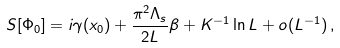Convert formula to latex. <formula><loc_0><loc_0><loc_500><loc_500>S [ \Phi _ { 0 } ] = i \gamma ( x _ { 0 } ) + \frac { \pi ^ { 2 } \Lambda _ { s } } { 2 L } \beta + K ^ { - 1 } \ln L + o ( L ^ { - 1 } ) \, ,</formula> 